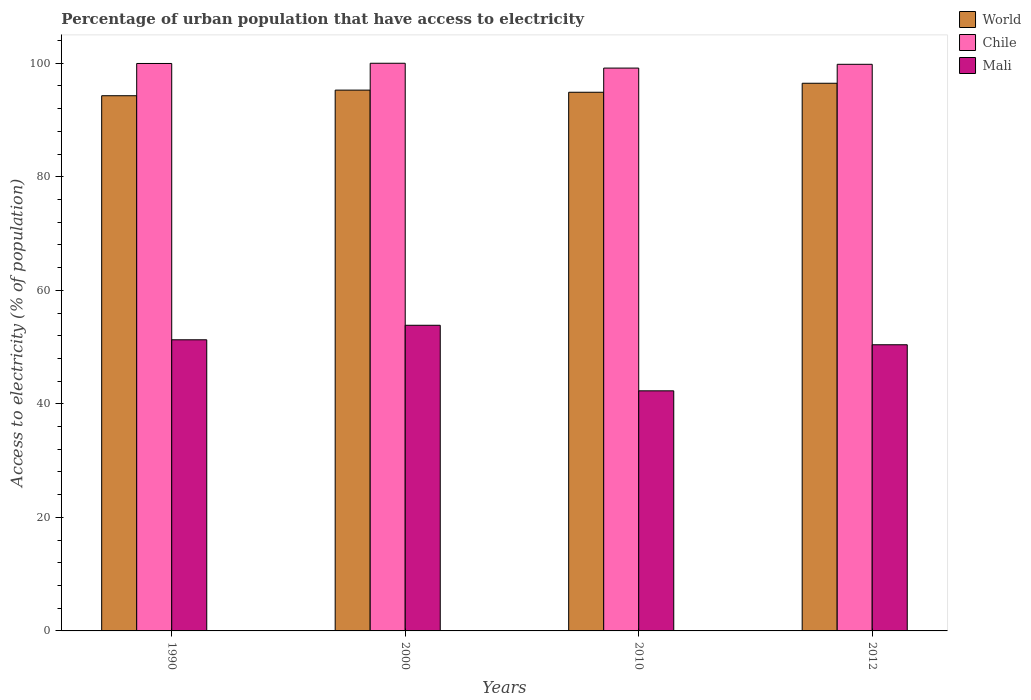How many different coloured bars are there?
Keep it short and to the point. 3. Are the number of bars on each tick of the X-axis equal?
Your answer should be compact. Yes. What is the label of the 4th group of bars from the left?
Offer a very short reply. 2012. In how many cases, is the number of bars for a given year not equal to the number of legend labels?
Make the answer very short. 0. What is the percentage of urban population that have access to electricity in Chile in 1990?
Provide a succinct answer. 99.96. Across all years, what is the minimum percentage of urban population that have access to electricity in World?
Offer a very short reply. 94.28. What is the total percentage of urban population that have access to electricity in World in the graph?
Your answer should be compact. 380.92. What is the difference between the percentage of urban population that have access to electricity in World in 2000 and that in 2012?
Keep it short and to the point. -1.21. What is the difference between the percentage of urban population that have access to electricity in World in 2000 and the percentage of urban population that have access to electricity in Chile in 2010?
Provide a succinct answer. -3.88. What is the average percentage of urban population that have access to electricity in Chile per year?
Make the answer very short. 99.73. In the year 2012, what is the difference between the percentage of urban population that have access to electricity in Chile and percentage of urban population that have access to electricity in Mali?
Make the answer very short. 49.4. What is the ratio of the percentage of urban population that have access to electricity in Mali in 1990 to that in 2010?
Keep it short and to the point. 1.21. Is the percentage of urban population that have access to electricity in World in 2000 less than that in 2012?
Offer a terse response. Yes. What is the difference between the highest and the second highest percentage of urban population that have access to electricity in Chile?
Offer a terse response. 0.04. What is the difference between the highest and the lowest percentage of urban population that have access to electricity in Chile?
Your response must be concise. 0.85. In how many years, is the percentage of urban population that have access to electricity in Mali greater than the average percentage of urban population that have access to electricity in Mali taken over all years?
Keep it short and to the point. 3. What does the 3rd bar from the left in 2000 represents?
Make the answer very short. Mali. What does the 2nd bar from the right in 2000 represents?
Make the answer very short. Chile. Are all the bars in the graph horizontal?
Your response must be concise. No. What is the difference between two consecutive major ticks on the Y-axis?
Your response must be concise. 20. Does the graph contain any zero values?
Offer a very short reply. No. Does the graph contain grids?
Provide a succinct answer. No. How are the legend labels stacked?
Keep it short and to the point. Vertical. What is the title of the graph?
Offer a terse response. Percentage of urban population that have access to electricity. Does "Uganda" appear as one of the legend labels in the graph?
Ensure brevity in your answer.  No. What is the label or title of the Y-axis?
Provide a succinct answer. Access to electricity (% of population). What is the Access to electricity (% of population) of World in 1990?
Ensure brevity in your answer.  94.28. What is the Access to electricity (% of population) in Chile in 1990?
Offer a very short reply. 99.96. What is the Access to electricity (% of population) in Mali in 1990?
Offer a terse response. 51.29. What is the Access to electricity (% of population) of World in 2000?
Keep it short and to the point. 95.27. What is the Access to electricity (% of population) of Mali in 2000?
Keep it short and to the point. 53.84. What is the Access to electricity (% of population) of World in 2010?
Your answer should be compact. 94.89. What is the Access to electricity (% of population) of Chile in 2010?
Keep it short and to the point. 99.15. What is the Access to electricity (% of population) of Mali in 2010?
Your answer should be very brief. 42.29. What is the Access to electricity (% of population) in World in 2012?
Your answer should be compact. 96.48. What is the Access to electricity (% of population) in Chile in 2012?
Provide a short and direct response. 99.81. What is the Access to electricity (% of population) of Mali in 2012?
Give a very brief answer. 50.41. Across all years, what is the maximum Access to electricity (% of population) of World?
Keep it short and to the point. 96.48. Across all years, what is the maximum Access to electricity (% of population) of Chile?
Keep it short and to the point. 100. Across all years, what is the maximum Access to electricity (% of population) of Mali?
Keep it short and to the point. 53.84. Across all years, what is the minimum Access to electricity (% of population) of World?
Give a very brief answer. 94.28. Across all years, what is the minimum Access to electricity (% of population) of Chile?
Your response must be concise. 99.15. Across all years, what is the minimum Access to electricity (% of population) of Mali?
Your answer should be compact. 42.29. What is the total Access to electricity (% of population) of World in the graph?
Ensure brevity in your answer.  380.92. What is the total Access to electricity (% of population) in Chile in the graph?
Offer a very short reply. 398.93. What is the total Access to electricity (% of population) in Mali in the graph?
Your answer should be very brief. 197.83. What is the difference between the Access to electricity (% of population) of World in 1990 and that in 2000?
Keep it short and to the point. -0.99. What is the difference between the Access to electricity (% of population) of Chile in 1990 and that in 2000?
Your answer should be compact. -0.04. What is the difference between the Access to electricity (% of population) in Mali in 1990 and that in 2000?
Provide a succinct answer. -2.56. What is the difference between the Access to electricity (% of population) of World in 1990 and that in 2010?
Give a very brief answer. -0.61. What is the difference between the Access to electricity (% of population) of Chile in 1990 and that in 2010?
Provide a succinct answer. 0.81. What is the difference between the Access to electricity (% of population) of Mali in 1990 and that in 2010?
Your answer should be compact. 8.99. What is the difference between the Access to electricity (% of population) of World in 1990 and that in 2012?
Make the answer very short. -2.2. What is the difference between the Access to electricity (% of population) of Chile in 1990 and that in 2012?
Provide a succinct answer. 0.15. What is the difference between the Access to electricity (% of population) of Mali in 1990 and that in 2012?
Your answer should be very brief. 0.88. What is the difference between the Access to electricity (% of population) in World in 2000 and that in 2010?
Make the answer very short. 0.38. What is the difference between the Access to electricity (% of population) of Chile in 2000 and that in 2010?
Make the answer very short. 0.85. What is the difference between the Access to electricity (% of population) of Mali in 2000 and that in 2010?
Provide a succinct answer. 11.55. What is the difference between the Access to electricity (% of population) of World in 2000 and that in 2012?
Your answer should be compact. -1.21. What is the difference between the Access to electricity (% of population) in Chile in 2000 and that in 2012?
Your response must be concise. 0.19. What is the difference between the Access to electricity (% of population) in Mali in 2000 and that in 2012?
Your response must be concise. 3.43. What is the difference between the Access to electricity (% of population) in World in 2010 and that in 2012?
Offer a very short reply. -1.59. What is the difference between the Access to electricity (% of population) in Chile in 2010 and that in 2012?
Offer a very short reply. -0.67. What is the difference between the Access to electricity (% of population) in Mali in 2010 and that in 2012?
Give a very brief answer. -8.12. What is the difference between the Access to electricity (% of population) of World in 1990 and the Access to electricity (% of population) of Chile in 2000?
Provide a short and direct response. -5.72. What is the difference between the Access to electricity (% of population) in World in 1990 and the Access to electricity (% of population) in Mali in 2000?
Make the answer very short. 40.44. What is the difference between the Access to electricity (% of population) of Chile in 1990 and the Access to electricity (% of population) of Mali in 2000?
Your answer should be very brief. 46.12. What is the difference between the Access to electricity (% of population) of World in 1990 and the Access to electricity (% of population) of Chile in 2010?
Give a very brief answer. -4.87. What is the difference between the Access to electricity (% of population) of World in 1990 and the Access to electricity (% of population) of Mali in 2010?
Provide a succinct answer. 51.99. What is the difference between the Access to electricity (% of population) of Chile in 1990 and the Access to electricity (% of population) of Mali in 2010?
Ensure brevity in your answer.  57.67. What is the difference between the Access to electricity (% of population) in World in 1990 and the Access to electricity (% of population) in Chile in 2012?
Keep it short and to the point. -5.54. What is the difference between the Access to electricity (% of population) in World in 1990 and the Access to electricity (% of population) in Mali in 2012?
Offer a terse response. 43.87. What is the difference between the Access to electricity (% of population) of Chile in 1990 and the Access to electricity (% of population) of Mali in 2012?
Your answer should be very brief. 49.55. What is the difference between the Access to electricity (% of population) of World in 2000 and the Access to electricity (% of population) of Chile in 2010?
Ensure brevity in your answer.  -3.88. What is the difference between the Access to electricity (% of population) of World in 2000 and the Access to electricity (% of population) of Mali in 2010?
Your answer should be compact. 52.98. What is the difference between the Access to electricity (% of population) of Chile in 2000 and the Access to electricity (% of population) of Mali in 2010?
Keep it short and to the point. 57.71. What is the difference between the Access to electricity (% of population) in World in 2000 and the Access to electricity (% of population) in Chile in 2012?
Your answer should be compact. -4.55. What is the difference between the Access to electricity (% of population) in World in 2000 and the Access to electricity (% of population) in Mali in 2012?
Keep it short and to the point. 44.86. What is the difference between the Access to electricity (% of population) in Chile in 2000 and the Access to electricity (% of population) in Mali in 2012?
Your response must be concise. 49.59. What is the difference between the Access to electricity (% of population) in World in 2010 and the Access to electricity (% of population) in Chile in 2012?
Offer a terse response. -4.92. What is the difference between the Access to electricity (% of population) of World in 2010 and the Access to electricity (% of population) of Mali in 2012?
Make the answer very short. 44.48. What is the difference between the Access to electricity (% of population) of Chile in 2010 and the Access to electricity (% of population) of Mali in 2012?
Provide a short and direct response. 48.74. What is the average Access to electricity (% of population) in World per year?
Provide a short and direct response. 95.23. What is the average Access to electricity (% of population) of Chile per year?
Offer a terse response. 99.73. What is the average Access to electricity (% of population) in Mali per year?
Give a very brief answer. 49.46. In the year 1990, what is the difference between the Access to electricity (% of population) in World and Access to electricity (% of population) in Chile?
Provide a succinct answer. -5.68. In the year 1990, what is the difference between the Access to electricity (% of population) in World and Access to electricity (% of population) in Mali?
Offer a very short reply. 42.99. In the year 1990, what is the difference between the Access to electricity (% of population) in Chile and Access to electricity (% of population) in Mali?
Ensure brevity in your answer.  48.68. In the year 2000, what is the difference between the Access to electricity (% of population) of World and Access to electricity (% of population) of Chile?
Make the answer very short. -4.73. In the year 2000, what is the difference between the Access to electricity (% of population) of World and Access to electricity (% of population) of Mali?
Your answer should be compact. 41.43. In the year 2000, what is the difference between the Access to electricity (% of population) in Chile and Access to electricity (% of population) in Mali?
Provide a short and direct response. 46.16. In the year 2010, what is the difference between the Access to electricity (% of population) of World and Access to electricity (% of population) of Chile?
Make the answer very short. -4.26. In the year 2010, what is the difference between the Access to electricity (% of population) in World and Access to electricity (% of population) in Mali?
Provide a short and direct response. 52.6. In the year 2010, what is the difference between the Access to electricity (% of population) of Chile and Access to electricity (% of population) of Mali?
Give a very brief answer. 56.86. In the year 2012, what is the difference between the Access to electricity (% of population) in World and Access to electricity (% of population) in Chile?
Provide a short and direct response. -3.34. In the year 2012, what is the difference between the Access to electricity (% of population) of World and Access to electricity (% of population) of Mali?
Your response must be concise. 46.07. In the year 2012, what is the difference between the Access to electricity (% of population) of Chile and Access to electricity (% of population) of Mali?
Give a very brief answer. 49.4. What is the ratio of the Access to electricity (% of population) in Mali in 1990 to that in 2000?
Your answer should be compact. 0.95. What is the ratio of the Access to electricity (% of population) in World in 1990 to that in 2010?
Keep it short and to the point. 0.99. What is the ratio of the Access to electricity (% of population) in Chile in 1990 to that in 2010?
Keep it short and to the point. 1.01. What is the ratio of the Access to electricity (% of population) of Mali in 1990 to that in 2010?
Give a very brief answer. 1.21. What is the ratio of the Access to electricity (% of population) of World in 1990 to that in 2012?
Your response must be concise. 0.98. What is the ratio of the Access to electricity (% of population) in Mali in 1990 to that in 2012?
Provide a short and direct response. 1.02. What is the ratio of the Access to electricity (% of population) in Chile in 2000 to that in 2010?
Your response must be concise. 1.01. What is the ratio of the Access to electricity (% of population) of Mali in 2000 to that in 2010?
Provide a short and direct response. 1.27. What is the ratio of the Access to electricity (% of population) of World in 2000 to that in 2012?
Make the answer very short. 0.99. What is the ratio of the Access to electricity (% of population) of Mali in 2000 to that in 2012?
Provide a succinct answer. 1.07. What is the ratio of the Access to electricity (% of population) of World in 2010 to that in 2012?
Give a very brief answer. 0.98. What is the ratio of the Access to electricity (% of population) in Mali in 2010 to that in 2012?
Offer a very short reply. 0.84. What is the difference between the highest and the second highest Access to electricity (% of population) in World?
Ensure brevity in your answer.  1.21. What is the difference between the highest and the second highest Access to electricity (% of population) in Chile?
Ensure brevity in your answer.  0.04. What is the difference between the highest and the second highest Access to electricity (% of population) in Mali?
Offer a very short reply. 2.56. What is the difference between the highest and the lowest Access to electricity (% of population) in World?
Make the answer very short. 2.2. What is the difference between the highest and the lowest Access to electricity (% of population) in Chile?
Your response must be concise. 0.85. What is the difference between the highest and the lowest Access to electricity (% of population) in Mali?
Offer a very short reply. 11.55. 